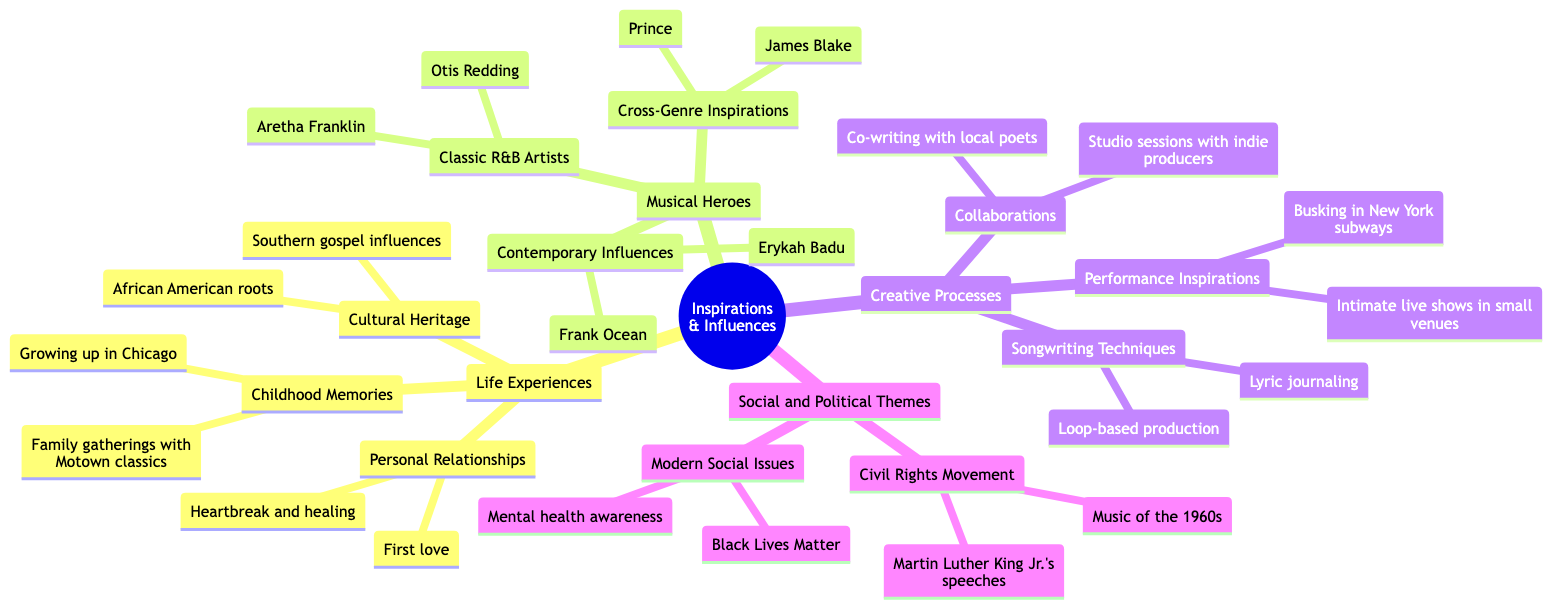What are the two subcategories under Life Experiences? The main category "Life Experiences" has three subcategories: "Childhood Memories," "Personal Relationships," and "Cultural Heritage." The question specifically asks for two of these, so any two from this list, such as "Childhood Memories" and "Personal Relationships," can be the answer.
Answer: Childhood Memories, Personal Relationships Who are two Classic R&B Artists listed? Under the "Musical Heroes" category, the subcategory "Classic R&B Artists" includes two artists: "Aretha Franklin" and "Otis Redding." The question refers to this specific subcategory, which makes it straightforward to answer.
Answer: Aretha Franklin, Otis Redding What influences are under Creative Processes? The "Creative Processes" main category includes three subcategories: "Songwriting Techniques," "Collaborations," and "Performance Inspirations." The question asks for the influences specifically listed under this main category, which consist of these three.
Answer: Songwriting Techniques, Collaborations, Performance Inspirations How many subcategories are listed under Social and Political Themes? The "Social and Political Themes" category includes two subcategories: "Civil Rights Movement" and "Modern Social Issues." To find the answer, we simply count these.
Answer: 2 Which Contemporary Influences are mentioned? The "Contemporary Influences" subcategory of "Musical Heroes" lists two influences: "Erykah Badu" and "Frank Ocean." This is a simple retrieval of the specific artists named in that category.
Answer: Erykah Badu, Frank Ocean What is one songwriting technique mentioned? The "Songwriting Techniques" subcategory under "Creative Processes" includes two techniques: "Lyric journaling" and "Loop-based production." This question asks for any one of these, so either can serve as the answer.
Answer: Lyric journaling Which historical figure is referenced in the Civil Rights Movement theme? Under the "Civil Rights Movement" subcategory of "Social and Political Themes," the diagram mentions "Martin Luther King Jr.'s speeches." Therefore, the answer can be directly taken from this subcategory.
Answer: Martin Luther King Jr.'s speeches Which location is mentioned under Performance Inspirations? "Busking in New York subways" is explicitly listed under "Performance Inspirations" in the "Creative Processes" category. This question asks for a specific detail that can be found directly within the diagram.
Answer: Busking in New York subways What type of themes are reflected in the Social and Political Themes section? The main category "Social and Political Themes" includes two specified types: "Civil Rights Movement" and "Modern Social Issues." The question asks for the types reflected, making it clear that we are looking for the overarching themes.
Answer: Civil Rights Movement, Modern Social Issues 